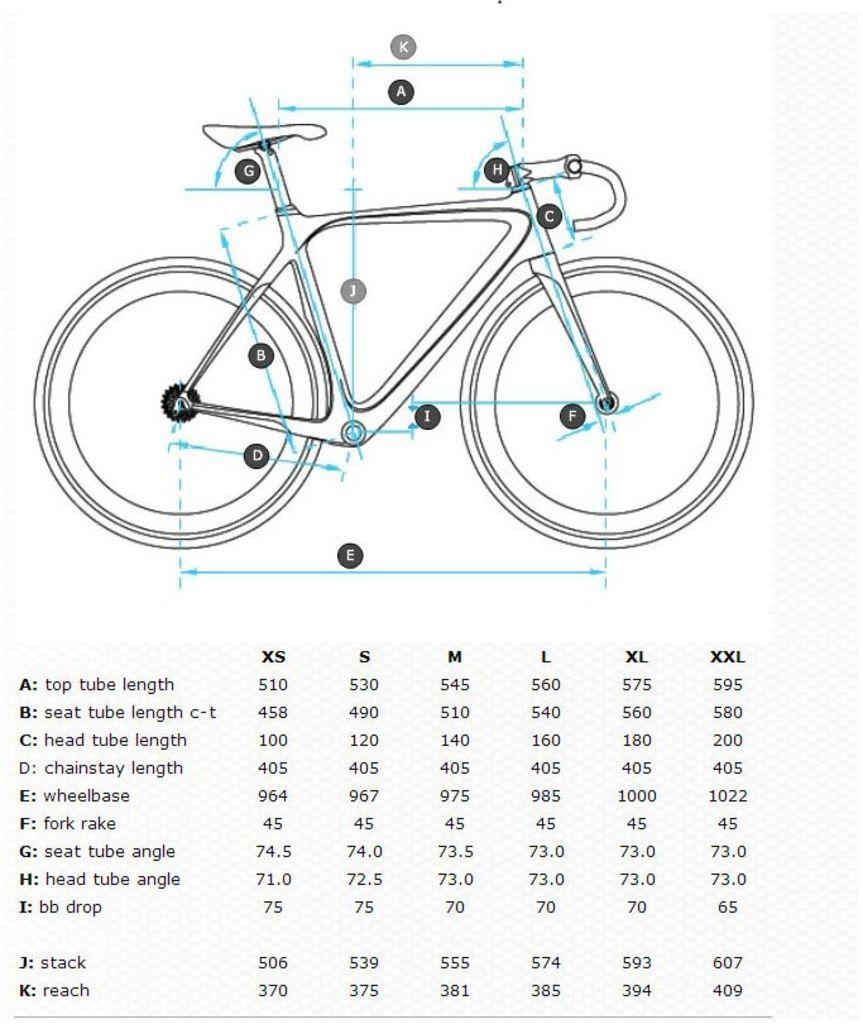What part is listed with the letter f?
Offer a terse response. Fork rake. What does the label d indicate?
Provide a succinct answer. Chainstay length. 